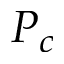Convert formula to latex. <formula><loc_0><loc_0><loc_500><loc_500>P _ { c }</formula> 